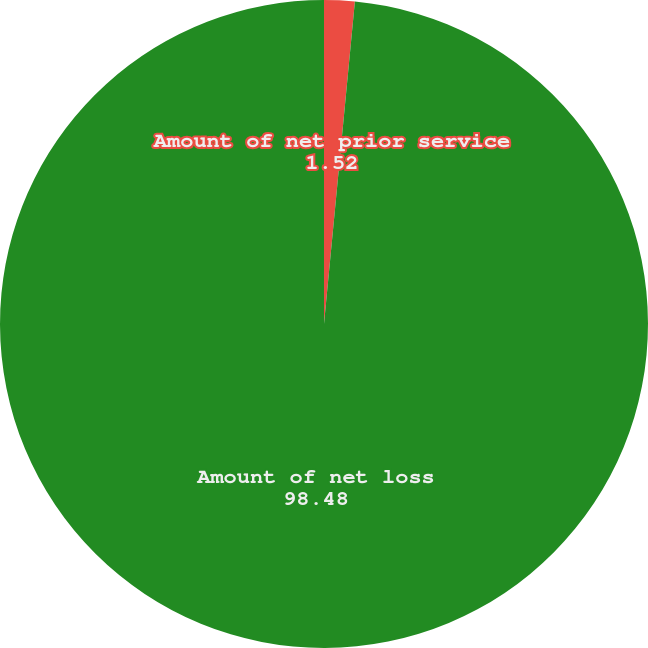Convert chart to OTSL. <chart><loc_0><loc_0><loc_500><loc_500><pie_chart><fcel>Amount of net prior service<fcel>Amount of net loss<nl><fcel>1.52%<fcel>98.48%<nl></chart> 